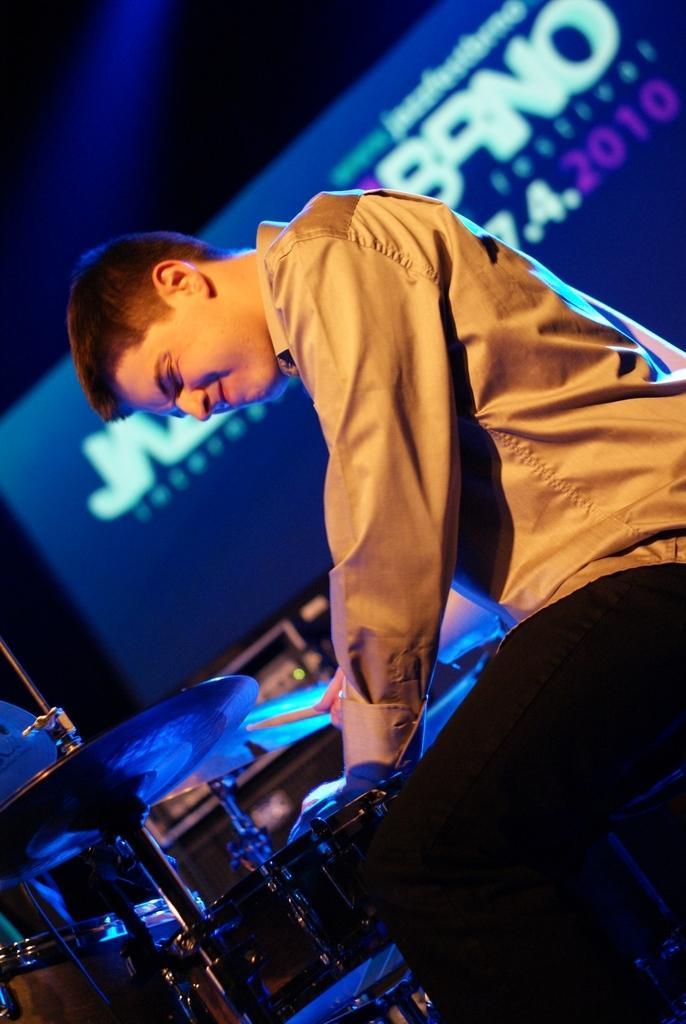Could you give a brief overview of what you see in this image? In the picture I can see a man wearing a shirt and he is playing the snare drum musical instrument. In the background, I can see the screen and there is a text on the screen. 